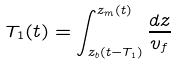Convert formula to latex. <formula><loc_0><loc_0><loc_500><loc_500>T _ { 1 } ( t ) = \int _ { z _ { b } ( t - T _ { 1 } ) } ^ { z _ { m } ( t ) } \frac { d z } { v _ { f } }</formula> 